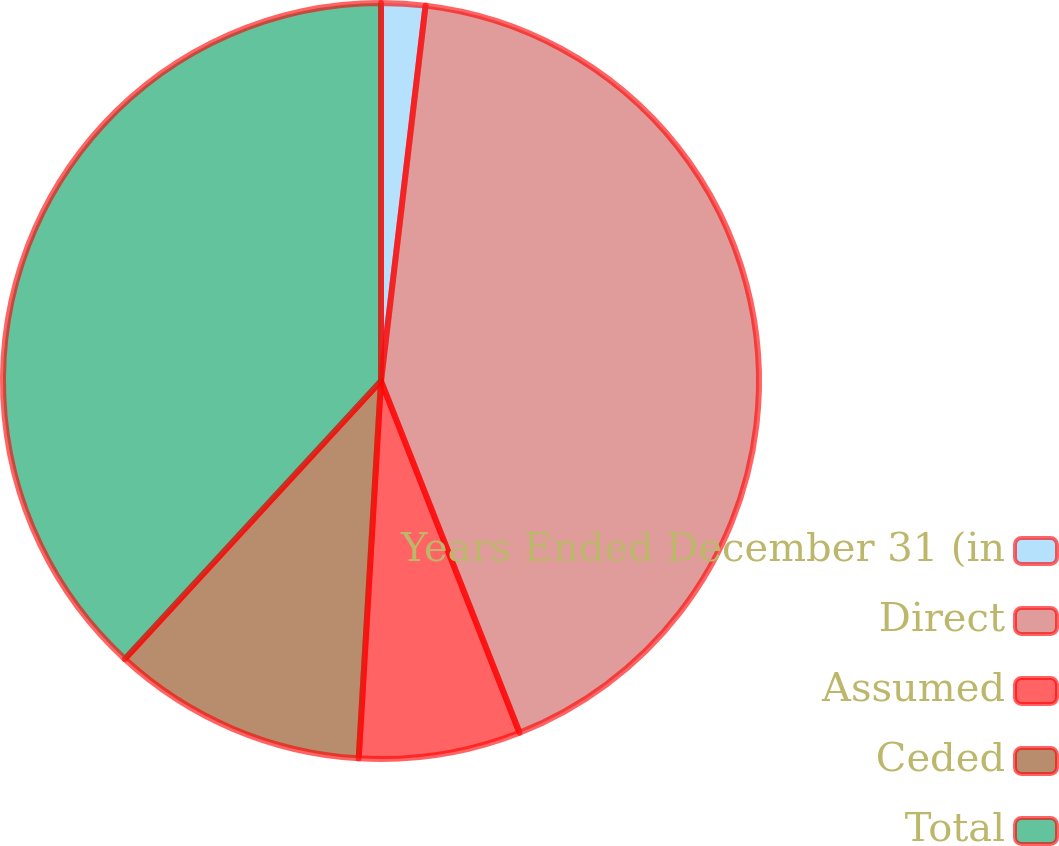Convert chart. <chart><loc_0><loc_0><loc_500><loc_500><pie_chart><fcel>Years Ended December 31 (in<fcel>Direct<fcel>Assumed<fcel>Ceded<fcel>Total<nl><fcel>1.88%<fcel>42.15%<fcel>6.91%<fcel>10.91%<fcel>38.15%<nl></chart> 